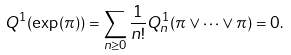<formula> <loc_0><loc_0><loc_500><loc_500>Q ^ { 1 } ( \exp ( \pi ) ) = \sum _ { n \geq 0 } \frac { 1 } { n ! } Q _ { n } ^ { 1 } ( \pi \vee \cdots \vee \pi ) = 0 .</formula> 